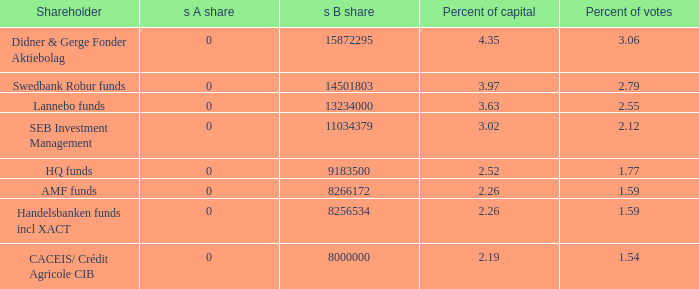What is the percent of capital for the shareholder that has a s B share of 8256534?  2.26. 